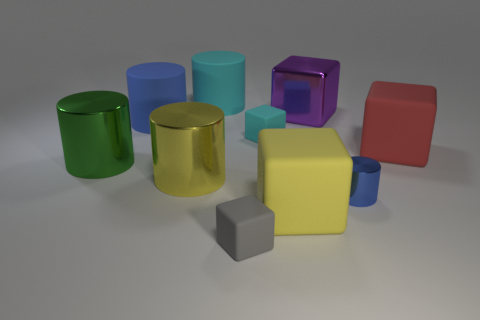Subtract 2 cylinders. How many cylinders are left? 3 Subtract all green cylinders. How many cylinders are left? 4 Subtract all green blocks. Subtract all cyan cylinders. How many blocks are left? 5 Add 8 large purple objects. How many large purple objects are left? 9 Add 6 yellow objects. How many yellow objects exist? 8 Subtract 1 cyan blocks. How many objects are left? 9 Subtract all large red rubber blocks. Subtract all small brown balls. How many objects are left? 9 